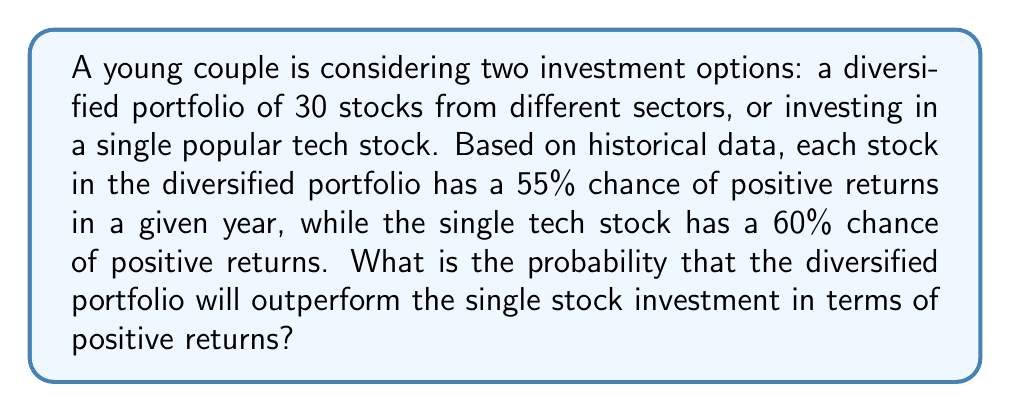Show me your answer to this math problem. To solve this problem, we need to consider the probability of the diversified portfolio having positive returns compared to the single stock.

1. For the diversified portfolio:
   - We need at least 16 out of 30 stocks to have positive returns to outperform the single stock (16/30 ≈ 53.33% > 50%).
   - This scenario follows a binomial distribution with n = 30 and p = 0.55.
   - We can calculate the probability of 16 or more stocks having positive returns using the cumulative binomial probability formula:

   $$ P(\text{Diversified outperforms}) = \sum_{k=16}^{30} \binom{30}{k} (0.55)^k (0.45)^{30-k} $$

2. For the single stock:
   - The probability of positive returns is simply 60% or 0.60.

3. To find the probability of the diversified portfolio outperforming:
   - We multiply the probability of the diversified portfolio having 16 or more positive returns by the probability of the single stock having negative returns.

   $$ P(\text{Diversified outperforms}) \times (1 - P(\text{Single stock positive})) $$

4. Calculating using a calculator or programming language:
   - $P(\text{Diversified outperforms}) \approx 0.8744$
   - $P(\text{Single stock negative}) = 1 - 0.60 = 0.40$

5. Final calculation:
   $$ 0.8744 \times 0.40 \approx 0.3498 $$

Therefore, the probability that the diversified portfolio will outperform the single stock investment is approximately 0.3498 or 34.98%.
Answer: The probability that the diversified portfolio will outperform the single stock investment is approximately 0.3498 or 34.98%. 